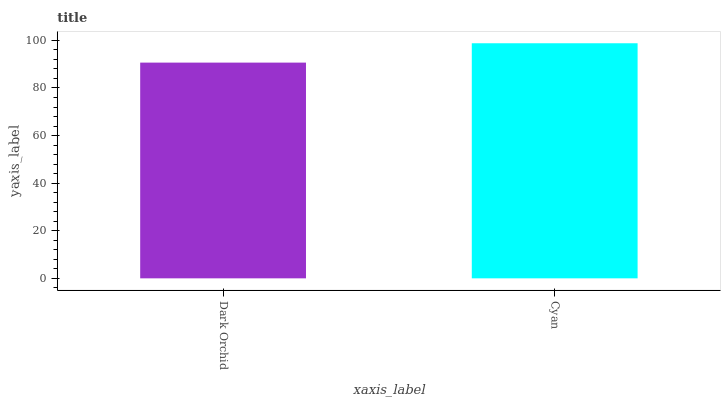Is Dark Orchid the minimum?
Answer yes or no. Yes. Is Cyan the maximum?
Answer yes or no. Yes. Is Cyan the minimum?
Answer yes or no. No. Is Cyan greater than Dark Orchid?
Answer yes or no. Yes. Is Dark Orchid less than Cyan?
Answer yes or no. Yes. Is Dark Orchid greater than Cyan?
Answer yes or no. No. Is Cyan less than Dark Orchid?
Answer yes or no. No. Is Cyan the high median?
Answer yes or no. Yes. Is Dark Orchid the low median?
Answer yes or no. Yes. Is Dark Orchid the high median?
Answer yes or no. No. Is Cyan the low median?
Answer yes or no. No. 